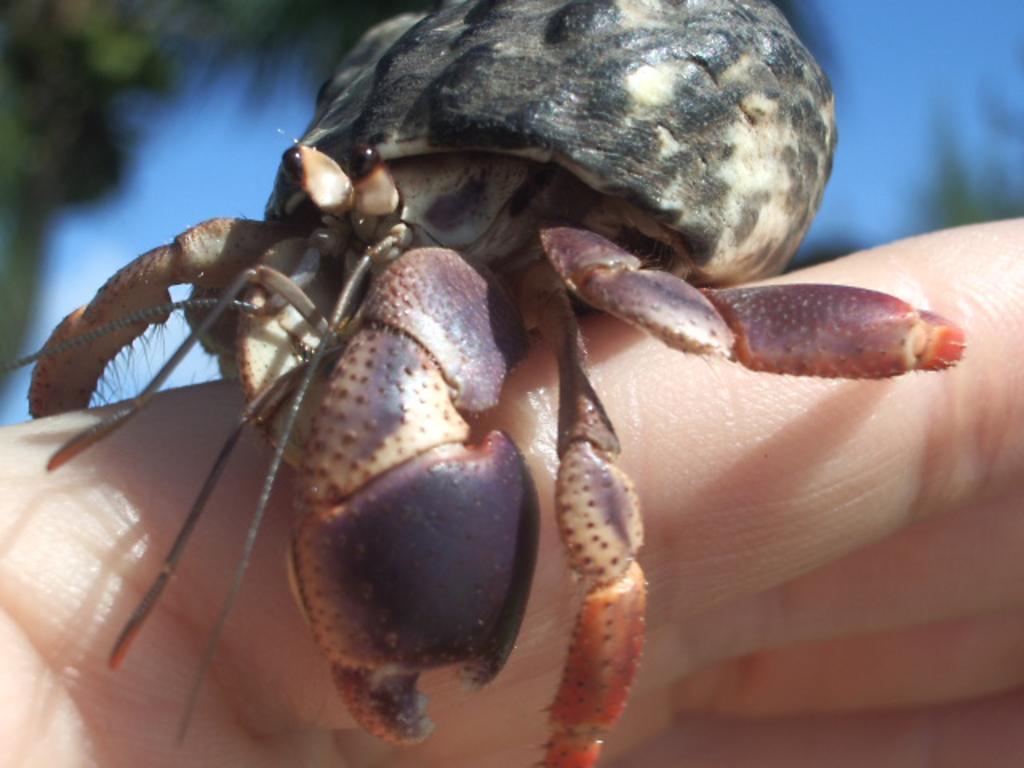Can you describe this image briefly? In this image we can see a crab on the fingers. There is a blur background and we can see sky. 